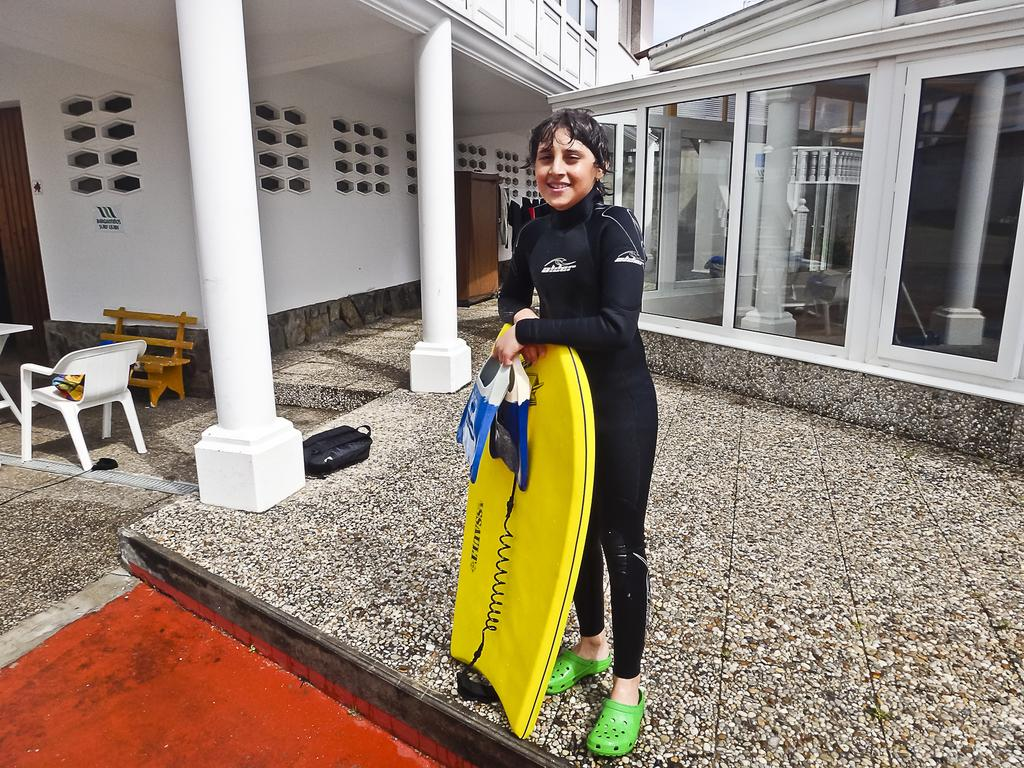What is the person in the image doing? The person is standing in the image and holding a surfing board. What can be seen in the background of the image? There are buildings, chairs, and a bench in the background of the image. How many kittens are sitting on the surfing board in the image? There are no kittens present in the image. Does the concept of existence have any relevance to the objects in the image? The concept of existence is not relevant to the objects in the image, as they are already present and visible. Can you see a giraffe in the image? There is no giraffe present in the image. 